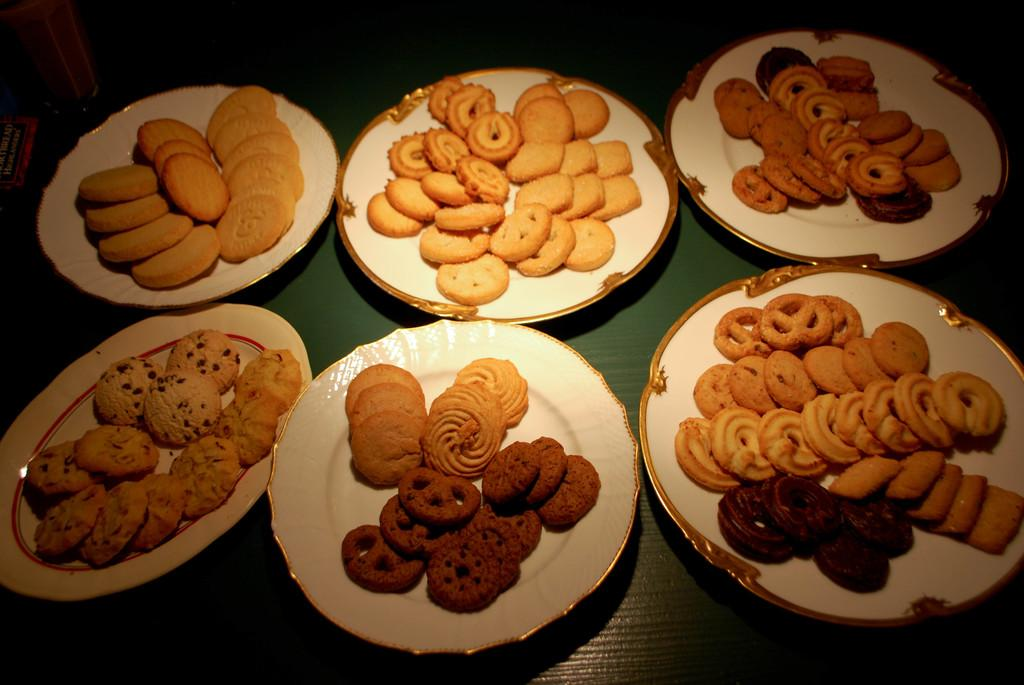What is on the plates that are visible in the image? The plates contain biscuits and cookies. Where are the plates located in the image? The plates are placed on a surface. What is on the left side of the image? There is a glass and an unspecified object on the left side of the image. What type of magic is being performed with the biscuits and cookies in the image? There is no magic being performed in the image; it simply shows plates with biscuits and cookies on a surface. 